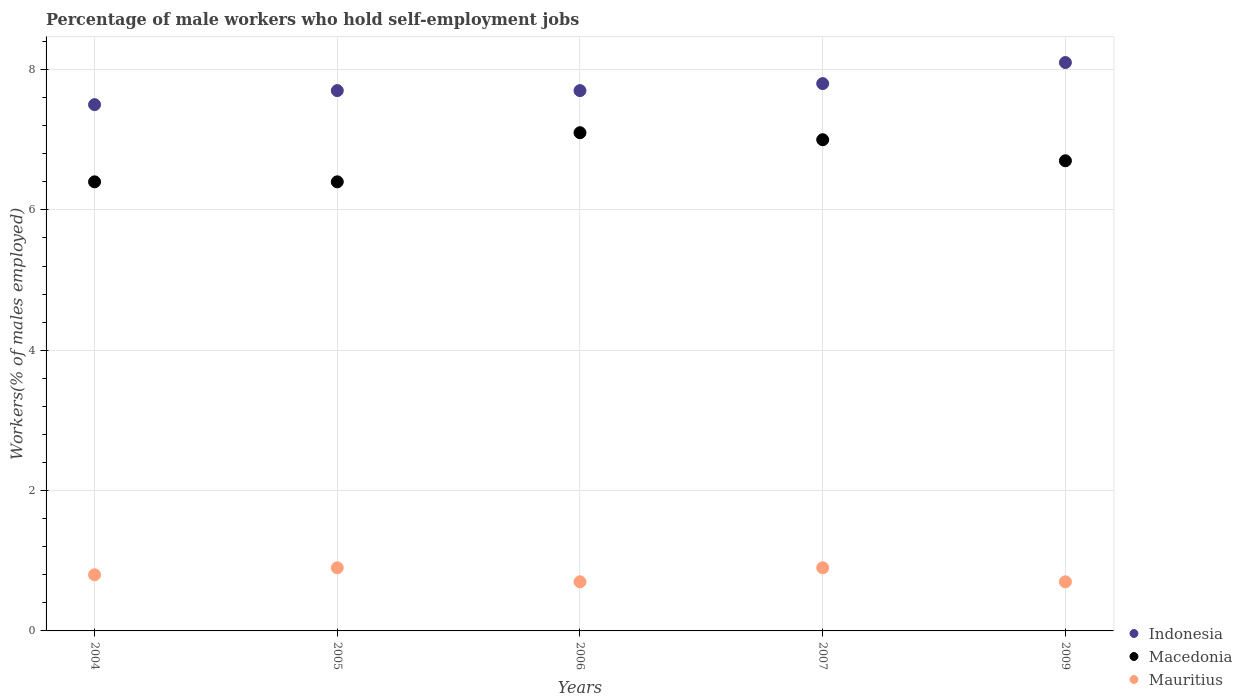Is the number of dotlines equal to the number of legend labels?
Offer a terse response. Yes. What is the percentage of self-employed male workers in Macedonia in 2005?
Your answer should be very brief. 6.4. Across all years, what is the maximum percentage of self-employed male workers in Indonesia?
Provide a short and direct response. 8.1. Across all years, what is the minimum percentage of self-employed male workers in Macedonia?
Provide a short and direct response. 6.4. In which year was the percentage of self-employed male workers in Macedonia maximum?
Keep it short and to the point. 2006. In which year was the percentage of self-employed male workers in Mauritius minimum?
Ensure brevity in your answer.  2006. What is the total percentage of self-employed male workers in Macedonia in the graph?
Keep it short and to the point. 33.6. What is the difference between the percentage of self-employed male workers in Macedonia in 2005 and that in 2009?
Provide a short and direct response. -0.3. What is the difference between the percentage of self-employed male workers in Macedonia in 2006 and the percentage of self-employed male workers in Mauritius in 2007?
Ensure brevity in your answer.  6.2. What is the average percentage of self-employed male workers in Indonesia per year?
Provide a succinct answer. 7.76. In the year 2005, what is the difference between the percentage of self-employed male workers in Mauritius and percentage of self-employed male workers in Indonesia?
Make the answer very short. -6.8. Is the percentage of self-employed male workers in Macedonia in 2005 less than that in 2007?
Offer a terse response. Yes. What is the difference between the highest and the second highest percentage of self-employed male workers in Indonesia?
Your answer should be very brief. 0.3. What is the difference between the highest and the lowest percentage of self-employed male workers in Mauritius?
Your answer should be very brief. 0.2. In how many years, is the percentage of self-employed male workers in Macedonia greater than the average percentage of self-employed male workers in Macedonia taken over all years?
Provide a succinct answer. 2. Is the sum of the percentage of self-employed male workers in Mauritius in 2005 and 2006 greater than the maximum percentage of self-employed male workers in Indonesia across all years?
Provide a short and direct response. No. How many dotlines are there?
Offer a very short reply. 3. What is the difference between two consecutive major ticks on the Y-axis?
Offer a terse response. 2. Are the values on the major ticks of Y-axis written in scientific E-notation?
Offer a terse response. No. Does the graph contain grids?
Provide a succinct answer. Yes. How are the legend labels stacked?
Your answer should be compact. Vertical. What is the title of the graph?
Ensure brevity in your answer.  Percentage of male workers who hold self-employment jobs. Does "Panama" appear as one of the legend labels in the graph?
Your response must be concise. No. What is the label or title of the X-axis?
Ensure brevity in your answer.  Years. What is the label or title of the Y-axis?
Ensure brevity in your answer.  Workers(% of males employed). What is the Workers(% of males employed) of Indonesia in 2004?
Your answer should be compact. 7.5. What is the Workers(% of males employed) of Macedonia in 2004?
Keep it short and to the point. 6.4. What is the Workers(% of males employed) of Mauritius in 2004?
Your answer should be compact. 0.8. What is the Workers(% of males employed) of Indonesia in 2005?
Your answer should be very brief. 7.7. What is the Workers(% of males employed) of Macedonia in 2005?
Your answer should be very brief. 6.4. What is the Workers(% of males employed) in Mauritius in 2005?
Give a very brief answer. 0.9. What is the Workers(% of males employed) of Indonesia in 2006?
Offer a terse response. 7.7. What is the Workers(% of males employed) of Macedonia in 2006?
Give a very brief answer. 7.1. What is the Workers(% of males employed) in Mauritius in 2006?
Offer a very short reply. 0.7. What is the Workers(% of males employed) of Indonesia in 2007?
Keep it short and to the point. 7.8. What is the Workers(% of males employed) in Mauritius in 2007?
Offer a terse response. 0.9. What is the Workers(% of males employed) in Indonesia in 2009?
Your answer should be very brief. 8.1. What is the Workers(% of males employed) of Macedonia in 2009?
Keep it short and to the point. 6.7. What is the Workers(% of males employed) of Mauritius in 2009?
Give a very brief answer. 0.7. Across all years, what is the maximum Workers(% of males employed) in Indonesia?
Keep it short and to the point. 8.1. Across all years, what is the maximum Workers(% of males employed) of Macedonia?
Your answer should be compact. 7.1. Across all years, what is the maximum Workers(% of males employed) in Mauritius?
Your response must be concise. 0.9. Across all years, what is the minimum Workers(% of males employed) in Indonesia?
Keep it short and to the point. 7.5. Across all years, what is the minimum Workers(% of males employed) of Macedonia?
Give a very brief answer. 6.4. Across all years, what is the minimum Workers(% of males employed) in Mauritius?
Your answer should be compact. 0.7. What is the total Workers(% of males employed) of Indonesia in the graph?
Provide a short and direct response. 38.8. What is the total Workers(% of males employed) of Macedonia in the graph?
Provide a succinct answer. 33.6. What is the total Workers(% of males employed) of Mauritius in the graph?
Provide a succinct answer. 4. What is the difference between the Workers(% of males employed) in Mauritius in 2004 and that in 2006?
Offer a very short reply. 0.1. What is the difference between the Workers(% of males employed) of Indonesia in 2004 and that in 2007?
Your answer should be compact. -0.3. What is the difference between the Workers(% of males employed) of Macedonia in 2004 and that in 2007?
Keep it short and to the point. -0.6. What is the difference between the Workers(% of males employed) in Mauritius in 2004 and that in 2007?
Your answer should be compact. -0.1. What is the difference between the Workers(% of males employed) of Mauritius in 2004 and that in 2009?
Keep it short and to the point. 0.1. What is the difference between the Workers(% of males employed) of Indonesia in 2005 and that in 2006?
Your answer should be very brief. 0. What is the difference between the Workers(% of males employed) in Mauritius in 2005 and that in 2006?
Offer a very short reply. 0.2. What is the difference between the Workers(% of males employed) of Indonesia in 2005 and that in 2009?
Provide a succinct answer. -0.4. What is the difference between the Workers(% of males employed) of Macedonia in 2005 and that in 2009?
Your response must be concise. -0.3. What is the difference between the Workers(% of males employed) of Mauritius in 2005 and that in 2009?
Your answer should be very brief. 0.2. What is the difference between the Workers(% of males employed) in Indonesia in 2006 and that in 2009?
Your answer should be compact. -0.4. What is the difference between the Workers(% of males employed) of Macedonia in 2006 and that in 2009?
Make the answer very short. 0.4. What is the difference between the Workers(% of males employed) of Mauritius in 2006 and that in 2009?
Keep it short and to the point. 0. What is the difference between the Workers(% of males employed) in Indonesia in 2004 and the Workers(% of males employed) in Macedonia in 2005?
Provide a succinct answer. 1.1. What is the difference between the Workers(% of males employed) in Macedonia in 2004 and the Workers(% of males employed) in Mauritius in 2005?
Make the answer very short. 5.5. What is the difference between the Workers(% of males employed) in Indonesia in 2004 and the Workers(% of males employed) in Macedonia in 2006?
Your answer should be compact. 0.4. What is the difference between the Workers(% of males employed) in Indonesia in 2004 and the Workers(% of males employed) in Mauritius in 2007?
Give a very brief answer. 6.6. What is the difference between the Workers(% of males employed) in Macedonia in 2004 and the Workers(% of males employed) in Mauritius in 2007?
Keep it short and to the point. 5.5. What is the difference between the Workers(% of males employed) of Indonesia in 2004 and the Workers(% of males employed) of Macedonia in 2009?
Keep it short and to the point. 0.8. What is the difference between the Workers(% of males employed) in Macedonia in 2005 and the Workers(% of males employed) in Mauritius in 2006?
Your answer should be compact. 5.7. What is the difference between the Workers(% of males employed) of Indonesia in 2005 and the Workers(% of males employed) of Macedonia in 2007?
Offer a very short reply. 0.7. What is the difference between the Workers(% of males employed) of Macedonia in 2005 and the Workers(% of males employed) of Mauritius in 2007?
Your answer should be very brief. 5.5. What is the difference between the Workers(% of males employed) in Indonesia in 2005 and the Workers(% of males employed) in Mauritius in 2009?
Offer a very short reply. 7. What is the difference between the Workers(% of males employed) in Macedonia in 2005 and the Workers(% of males employed) in Mauritius in 2009?
Give a very brief answer. 5.7. What is the difference between the Workers(% of males employed) of Indonesia in 2006 and the Workers(% of males employed) of Macedonia in 2007?
Your answer should be very brief. 0.7. What is the difference between the Workers(% of males employed) of Indonesia in 2006 and the Workers(% of males employed) of Mauritius in 2009?
Make the answer very short. 7. What is the difference between the Workers(% of males employed) in Macedonia in 2006 and the Workers(% of males employed) in Mauritius in 2009?
Give a very brief answer. 6.4. What is the difference between the Workers(% of males employed) in Indonesia in 2007 and the Workers(% of males employed) in Macedonia in 2009?
Give a very brief answer. 1.1. What is the average Workers(% of males employed) of Indonesia per year?
Keep it short and to the point. 7.76. What is the average Workers(% of males employed) of Macedonia per year?
Give a very brief answer. 6.72. In the year 2004, what is the difference between the Workers(% of males employed) in Macedonia and Workers(% of males employed) in Mauritius?
Your response must be concise. 5.6. In the year 2005, what is the difference between the Workers(% of males employed) of Indonesia and Workers(% of males employed) of Macedonia?
Offer a very short reply. 1.3. In the year 2006, what is the difference between the Workers(% of males employed) in Macedonia and Workers(% of males employed) in Mauritius?
Provide a succinct answer. 6.4. In the year 2009, what is the difference between the Workers(% of males employed) of Indonesia and Workers(% of males employed) of Mauritius?
Your answer should be very brief. 7.4. In the year 2009, what is the difference between the Workers(% of males employed) in Macedonia and Workers(% of males employed) in Mauritius?
Your answer should be very brief. 6. What is the ratio of the Workers(% of males employed) in Indonesia in 2004 to that in 2006?
Give a very brief answer. 0.97. What is the ratio of the Workers(% of males employed) of Macedonia in 2004 to that in 2006?
Provide a succinct answer. 0.9. What is the ratio of the Workers(% of males employed) of Indonesia in 2004 to that in 2007?
Your response must be concise. 0.96. What is the ratio of the Workers(% of males employed) in Macedonia in 2004 to that in 2007?
Keep it short and to the point. 0.91. What is the ratio of the Workers(% of males employed) of Mauritius in 2004 to that in 2007?
Your answer should be very brief. 0.89. What is the ratio of the Workers(% of males employed) of Indonesia in 2004 to that in 2009?
Offer a terse response. 0.93. What is the ratio of the Workers(% of males employed) in Macedonia in 2004 to that in 2009?
Offer a terse response. 0.96. What is the ratio of the Workers(% of males employed) in Indonesia in 2005 to that in 2006?
Keep it short and to the point. 1. What is the ratio of the Workers(% of males employed) of Macedonia in 2005 to that in 2006?
Provide a short and direct response. 0.9. What is the ratio of the Workers(% of males employed) of Indonesia in 2005 to that in 2007?
Ensure brevity in your answer.  0.99. What is the ratio of the Workers(% of males employed) in Macedonia in 2005 to that in 2007?
Offer a very short reply. 0.91. What is the ratio of the Workers(% of males employed) of Indonesia in 2005 to that in 2009?
Ensure brevity in your answer.  0.95. What is the ratio of the Workers(% of males employed) of Macedonia in 2005 to that in 2009?
Keep it short and to the point. 0.96. What is the ratio of the Workers(% of males employed) in Mauritius in 2005 to that in 2009?
Keep it short and to the point. 1.29. What is the ratio of the Workers(% of males employed) in Indonesia in 2006 to that in 2007?
Give a very brief answer. 0.99. What is the ratio of the Workers(% of males employed) in Macedonia in 2006 to that in 2007?
Give a very brief answer. 1.01. What is the ratio of the Workers(% of males employed) of Indonesia in 2006 to that in 2009?
Make the answer very short. 0.95. What is the ratio of the Workers(% of males employed) in Macedonia in 2006 to that in 2009?
Your response must be concise. 1.06. What is the ratio of the Workers(% of males employed) in Mauritius in 2006 to that in 2009?
Keep it short and to the point. 1. What is the ratio of the Workers(% of males employed) in Indonesia in 2007 to that in 2009?
Your answer should be very brief. 0.96. What is the ratio of the Workers(% of males employed) in Macedonia in 2007 to that in 2009?
Offer a very short reply. 1.04. What is the ratio of the Workers(% of males employed) of Mauritius in 2007 to that in 2009?
Keep it short and to the point. 1.29. What is the difference between the highest and the second highest Workers(% of males employed) in Mauritius?
Offer a terse response. 0. What is the difference between the highest and the lowest Workers(% of males employed) in Macedonia?
Make the answer very short. 0.7. 